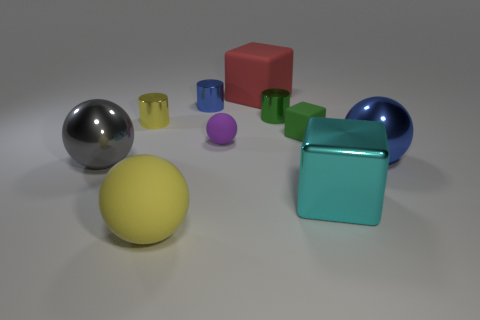Subtract all red blocks. How many blocks are left? 2 Subtract all tiny blue metal cylinders. How many cylinders are left? 2 Subtract 3 cylinders. How many cylinders are left? 0 Subtract all cubes. How many objects are left? 7 Subtract all green cylinders. Subtract all cyan spheres. How many cylinders are left? 2 Subtract all gray blocks. How many purple spheres are left? 1 Add 3 large rubber blocks. How many large rubber blocks exist? 4 Subtract 0 red spheres. How many objects are left? 10 Subtract all yellow balls. Subtract all blue metallic objects. How many objects are left? 7 Add 3 purple spheres. How many purple spheres are left? 4 